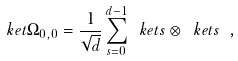<formula> <loc_0><loc_0><loc_500><loc_500>\ k e t { \Omega _ { 0 , 0 } } = \frac { 1 } { \sqrt { d } } \sum _ { s = 0 } ^ { d - 1 } \ k e t { s } \otimes \ k e t { s } \ ,</formula> 